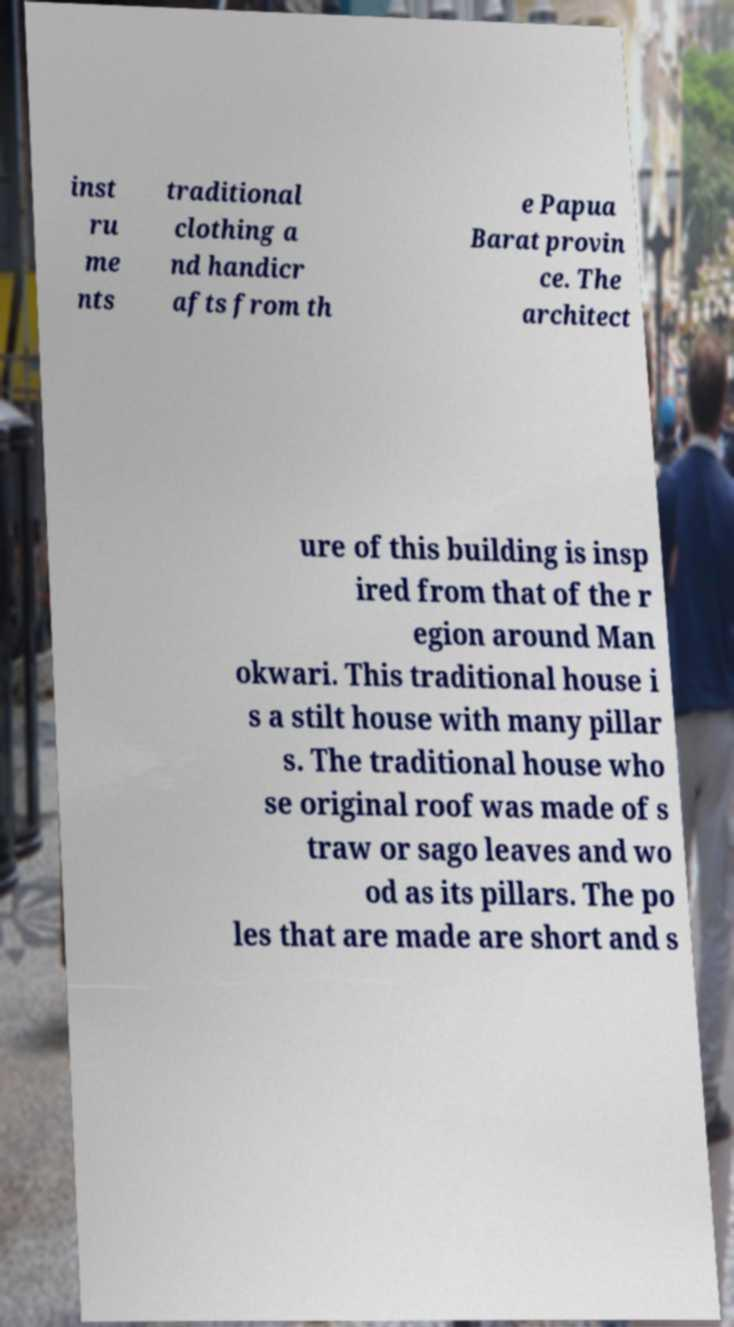Could you extract and type out the text from this image? inst ru me nts traditional clothing a nd handicr afts from th e Papua Barat provin ce. The architect ure of this building is insp ired from that of the r egion around Man okwari. This traditional house i s a stilt house with many pillar s. The traditional house who se original roof was made of s traw or sago leaves and wo od as its pillars. The po les that are made are short and s 